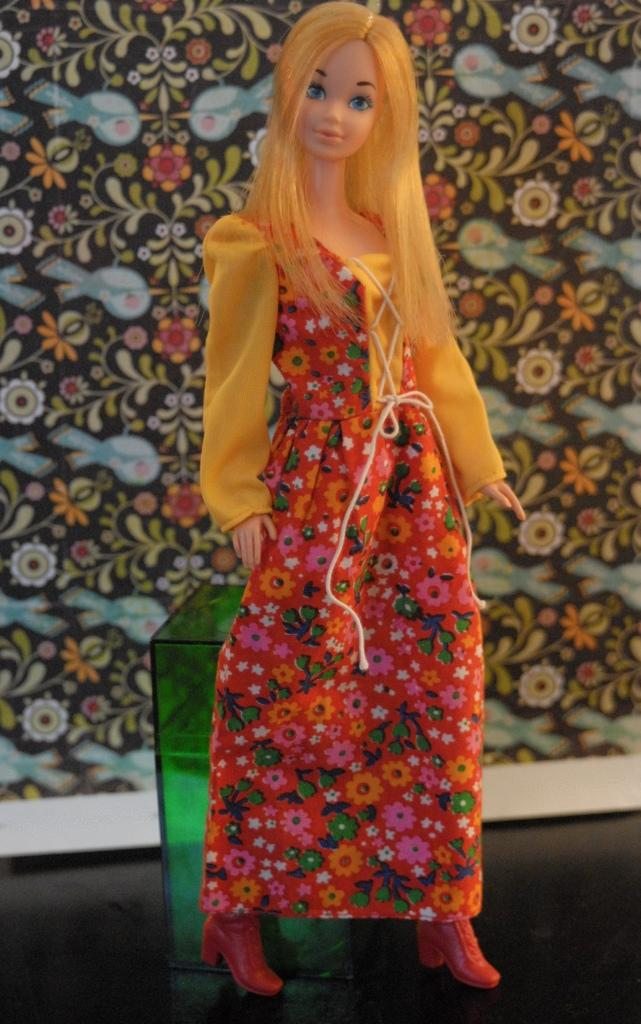What is the main subject of the image? There is a doll in the image. Where is the doll located in relation to other objects? The doll is in front of a box. What can be seen behind the doll? There is a design visible behind the doll. What type of coil is being used by the doll in the image? There is no coil present in the image, and the doll is not using any object. 